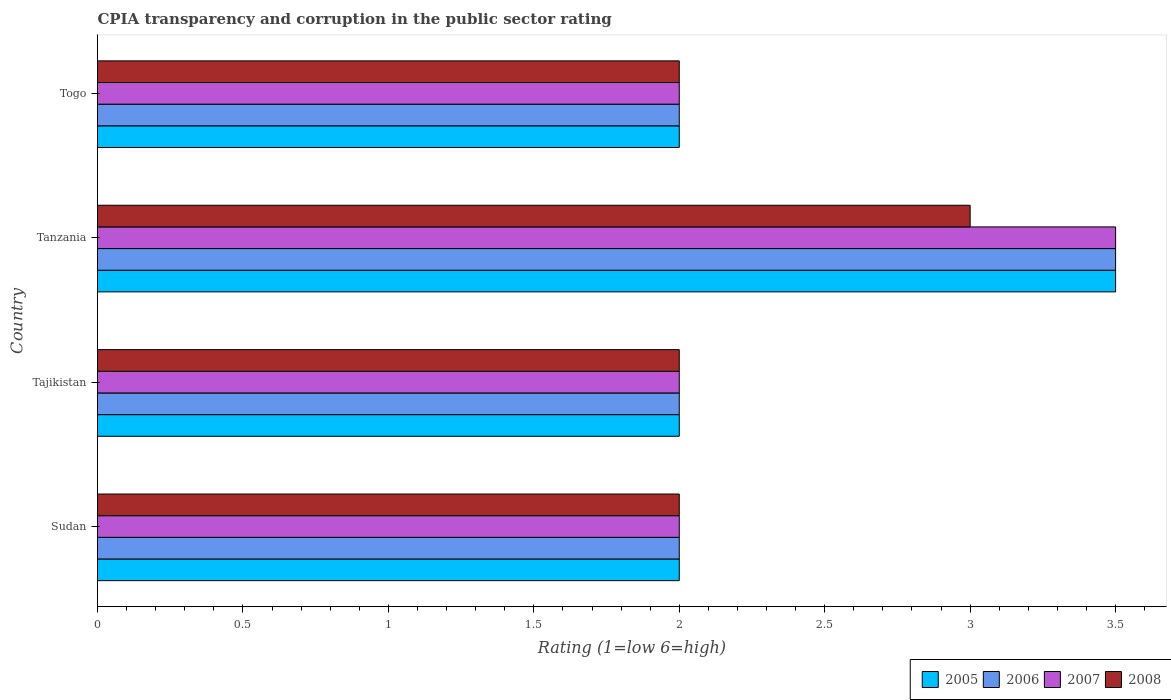How many different coloured bars are there?
Ensure brevity in your answer.  4. Are the number of bars per tick equal to the number of legend labels?
Provide a short and direct response. Yes. How many bars are there on the 3rd tick from the top?
Your answer should be compact. 4. What is the label of the 4th group of bars from the top?
Your answer should be very brief. Sudan. In how many cases, is the number of bars for a given country not equal to the number of legend labels?
Make the answer very short. 0. What is the CPIA rating in 2008 in Togo?
Your answer should be compact. 2. Across all countries, what is the maximum CPIA rating in 2008?
Make the answer very short. 3. In which country was the CPIA rating in 2005 maximum?
Offer a very short reply. Tanzania. In which country was the CPIA rating in 2007 minimum?
Provide a succinct answer. Sudan. What is the total CPIA rating in 2006 in the graph?
Ensure brevity in your answer.  9.5. What is the difference between the CPIA rating in 2006 in Togo and the CPIA rating in 2005 in Tanzania?
Keep it short and to the point. -1.5. What is the average CPIA rating in 2005 per country?
Keep it short and to the point. 2.38. What is the difference between the CPIA rating in 2006 and CPIA rating in 2007 in Sudan?
Offer a terse response. 0. What is the ratio of the CPIA rating in 2005 in Tajikistan to that in Tanzania?
Your answer should be compact. 0.57. Is the difference between the CPIA rating in 2006 in Tanzania and Togo greater than the difference between the CPIA rating in 2007 in Tanzania and Togo?
Provide a succinct answer. No. Is the sum of the CPIA rating in 2005 in Sudan and Togo greater than the maximum CPIA rating in 2006 across all countries?
Provide a succinct answer. Yes. What does the 3rd bar from the bottom in Tanzania represents?
Provide a succinct answer. 2007. Is it the case that in every country, the sum of the CPIA rating in 2006 and CPIA rating in 2008 is greater than the CPIA rating in 2005?
Provide a short and direct response. Yes. How many bars are there?
Your response must be concise. 16. What is the difference between two consecutive major ticks on the X-axis?
Offer a very short reply. 0.5. How many legend labels are there?
Provide a short and direct response. 4. What is the title of the graph?
Keep it short and to the point. CPIA transparency and corruption in the public sector rating. What is the Rating (1=low 6=high) of 2005 in Sudan?
Your answer should be very brief. 2. What is the Rating (1=low 6=high) in 2007 in Sudan?
Provide a short and direct response. 2. What is the Rating (1=low 6=high) in 2008 in Sudan?
Make the answer very short. 2. What is the Rating (1=low 6=high) in 2006 in Tajikistan?
Give a very brief answer. 2. What is the Rating (1=low 6=high) in 2008 in Tajikistan?
Offer a terse response. 2. What is the Rating (1=low 6=high) of 2005 in Tanzania?
Your answer should be very brief. 3.5. What is the Rating (1=low 6=high) in 2006 in Togo?
Your answer should be very brief. 2. What is the Rating (1=low 6=high) in 2007 in Togo?
Your answer should be very brief. 2. Across all countries, what is the maximum Rating (1=low 6=high) of 2006?
Your answer should be compact. 3.5. Across all countries, what is the minimum Rating (1=low 6=high) of 2005?
Give a very brief answer. 2. What is the total Rating (1=low 6=high) in 2007 in the graph?
Provide a short and direct response. 9.5. What is the difference between the Rating (1=low 6=high) in 2007 in Sudan and that in Tajikistan?
Make the answer very short. 0. What is the difference between the Rating (1=low 6=high) in 2008 in Sudan and that in Tajikistan?
Provide a succinct answer. 0. What is the difference between the Rating (1=low 6=high) in 2005 in Sudan and that in Tanzania?
Ensure brevity in your answer.  -1.5. What is the difference between the Rating (1=low 6=high) in 2006 in Sudan and that in Tanzania?
Your answer should be very brief. -1.5. What is the difference between the Rating (1=low 6=high) in 2005 in Sudan and that in Togo?
Provide a succinct answer. 0. What is the difference between the Rating (1=low 6=high) of 2006 in Sudan and that in Togo?
Offer a terse response. 0. What is the difference between the Rating (1=low 6=high) in 2008 in Sudan and that in Togo?
Ensure brevity in your answer.  0. What is the difference between the Rating (1=low 6=high) in 2005 in Tajikistan and that in Tanzania?
Ensure brevity in your answer.  -1.5. What is the difference between the Rating (1=low 6=high) of 2007 in Tajikistan and that in Tanzania?
Provide a succinct answer. -1.5. What is the difference between the Rating (1=low 6=high) in 2008 in Tajikistan and that in Tanzania?
Ensure brevity in your answer.  -1. What is the difference between the Rating (1=low 6=high) of 2005 in Tajikistan and that in Togo?
Make the answer very short. 0. What is the difference between the Rating (1=low 6=high) of 2006 in Tajikistan and that in Togo?
Your answer should be compact. 0. What is the difference between the Rating (1=low 6=high) in 2006 in Tanzania and that in Togo?
Make the answer very short. 1.5. What is the difference between the Rating (1=low 6=high) in 2007 in Tanzania and that in Togo?
Offer a terse response. 1.5. What is the difference between the Rating (1=low 6=high) of 2008 in Tanzania and that in Togo?
Provide a short and direct response. 1. What is the difference between the Rating (1=low 6=high) of 2005 in Sudan and the Rating (1=low 6=high) of 2006 in Tajikistan?
Offer a very short reply. 0. What is the difference between the Rating (1=low 6=high) in 2005 in Sudan and the Rating (1=low 6=high) in 2007 in Tajikistan?
Give a very brief answer. 0. What is the difference between the Rating (1=low 6=high) of 2005 in Sudan and the Rating (1=low 6=high) of 2008 in Tajikistan?
Provide a succinct answer. 0. What is the difference between the Rating (1=low 6=high) in 2006 in Sudan and the Rating (1=low 6=high) in 2007 in Tajikistan?
Your response must be concise. 0. What is the difference between the Rating (1=low 6=high) of 2007 in Sudan and the Rating (1=low 6=high) of 2008 in Tajikistan?
Provide a short and direct response. 0. What is the difference between the Rating (1=low 6=high) in 2005 in Sudan and the Rating (1=low 6=high) in 2007 in Tanzania?
Your answer should be very brief. -1.5. What is the difference between the Rating (1=low 6=high) of 2005 in Sudan and the Rating (1=low 6=high) of 2008 in Tanzania?
Make the answer very short. -1. What is the difference between the Rating (1=low 6=high) in 2007 in Sudan and the Rating (1=low 6=high) in 2008 in Tanzania?
Ensure brevity in your answer.  -1. What is the difference between the Rating (1=low 6=high) in 2005 in Sudan and the Rating (1=low 6=high) in 2007 in Togo?
Offer a very short reply. 0. What is the difference between the Rating (1=low 6=high) in 2006 in Sudan and the Rating (1=low 6=high) in 2007 in Togo?
Your answer should be very brief. 0. What is the difference between the Rating (1=low 6=high) of 2006 in Sudan and the Rating (1=low 6=high) of 2008 in Togo?
Your answer should be very brief. 0. What is the difference between the Rating (1=low 6=high) of 2005 in Tajikistan and the Rating (1=low 6=high) of 2006 in Tanzania?
Make the answer very short. -1.5. What is the difference between the Rating (1=low 6=high) in 2005 in Tajikistan and the Rating (1=low 6=high) in 2007 in Tanzania?
Your answer should be compact. -1.5. What is the difference between the Rating (1=low 6=high) in 2005 in Tajikistan and the Rating (1=low 6=high) in 2008 in Tanzania?
Offer a very short reply. -1. What is the difference between the Rating (1=low 6=high) of 2006 in Tajikistan and the Rating (1=low 6=high) of 2008 in Tanzania?
Provide a succinct answer. -1. What is the difference between the Rating (1=low 6=high) in 2005 in Tajikistan and the Rating (1=low 6=high) in 2006 in Togo?
Offer a very short reply. 0. What is the difference between the Rating (1=low 6=high) of 2005 in Tajikistan and the Rating (1=low 6=high) of 2007 in Togo?
Ensure brevity in your answer.  0. What is the difference between the Rating (1=low 6=high) in 2005 in Tajikistan and the Rating (1=low 6=high) in 2008 in Togo?
Offer a very short reply. 0. What is the difference between the Rating (1=low 6=high) in 2006 in Tajikistan and the Rating (1=low 6=high) in 2007 in Togo?
Give a very brief answer. 0. What is the difference between the Rating (1=low 6=high) in 2007 in Tajikistan and the Rating (1=low 6=high) in 2008 in Togo?
Provide a succinct answer. 0. What is the difference between the Rating (1=low 6=high) of 2005 in Tanzania and the Rating (1=low 6=high) of 2006 in Togo?
Provide a succinct answer. 1.5. What is the difference between the Rating (1=low 6=high) of 2005 in Tanzania and the Rating (1=low 6=high) of 2007 in Togo?
Your answer should be compact. 1.5. What is the difference between the Rating (1=low 6=high) in 2005 in Tanzania and the Rating (1=low 6=high) in 2008 in Togo?
Your answer should be compact. 1.5. What is the difference between the Rating (1=low 6=high) in 2006 in Tanzania and the Rating (1=low 6=high) in 2007 in Togo?
Your answer should be very brief. 1.5. What is the difference between the Rating (1=low 6=high) of 2006 in Tanzania and the Rating (1=low 6=high) of 2008 in Togo?
Give a very brief answer. 1.5. What is the difference between the Rating (1=low 6=high) in 2007 in Tanzania and the Rating (1=low 6=high) in 2008 in Togo?
Your response must be concise. 1.5. What is the average Rating (1=low 6=high) of 2005 per country?
Offer a very short reply. 2.38. What is the average Rating (1=low 6=high) of 2006 per country?
Make the answer very short. 2.38. What is the average Rating (1=low 6=high) in 2007 per country?
Your answer should be very brief. 2.38. What is the average Rating (1=low 6=high) in 2008 per country?
Offer a very short reply. 2.25. What is the difference between the Rating (1=low 6=high) of 2005 and Rating (1=low 6=high) of 2006 in Sudan?
Your response must be concise. 0. What is the difference between the Rating (1=low 6=high) in 2005 and Rating (1=low 6=high) in 2007 in Sudan?
Offer a terse response. 0. What is the difference between the Rating (1=low 6=high) in 2005 and Rating (1=low 6=high) in 2008 in Sudan?
Your response must be concise. 0. What is the difference between the Rating (1=low 6=high) of 2006 and Rating (1=low 6=high) of 2007 in Sudan?
Your answer should be very brief. 0. What is the difference between the Rating (1=low 6=high) of 2006 and Rating (1=low 6=high) of 2007 in Tajikistan?
Ensure brevity in your answer.  0. What is the difference between the Rating (1=low 6=high) of 2006 and Rating (1=low 6=high) of 2008 in Tajikistan?
Offer a very short reply. 0. What is the difference between the Rating (1=low 6=high) in 2005 and Rating (1=low 6=high) in 2008 in Tanzania?
Ensure brevity in your answer.  0.5. What is the difference between the Rating (1=low 6=high) in 2007 and Rating (1=low 6=high) in 2008 in Tanzania?
Ensure brevity in your answer.  0.5. What is the difference between the Rating (1=low 6=high) of 2005 and Rating (1=low 6=high) of 2008 in Togo?
Keep it short and to the point. 0. What is the ratio of the Rating (1=low 6=high) in 2005 in Sudan to that in Tajikistan?
Ensure brevity in your answer.  1. What is the ratio of the Rating (1=low 6=high) of 2007 in Sudan to that in Tajikistan?
Offer a terse response. 1. What is the ratio of the Rating (1=low 6=high) of 2008 in Sudan to that in Tajikistan?
Ensure brevity in your answer.  1. What is the ratio of the Rating (1=low 6=high) in 2006 in Sudan to that in Tanzania?
Provide a succinct answer. 0.57. What is the ratio of the Rating (1=low 6=high) of 2008 in Tajikistan to that in Togo?
Ensure brevity in your answer.  1. What is the ratio of the Rating (1=low 6=high) in 2007 in Tanzania to that in Togo?
Your answer should be very brief. 1.75. What is the ratio of the Rating (1=low 6=high) in 2008 in Tanzania to that in Togo?
Offer a very short reply. 1.5. What is the difference between the highest and the second highest Rating (1=low 6=high) of 2005?
Give a very brief answer. 1.5. What is the difference between the highest and the second highest Rating (1=low 6=high) of 2006?
Make the answer very short. 1.5. What is the difference between the highest and the second highest Rating (1=low 6=high) of 2007?
Make the answer very short. 1.5. What is the difference between the highest and the second highest Rating (1=low 6=high) in 2008?
Provide a succinct answer. 1. What is the difference between the highest and the lowest Rating (1=low 6=high) in 2006?
Give a very brief answer. 1.5. 